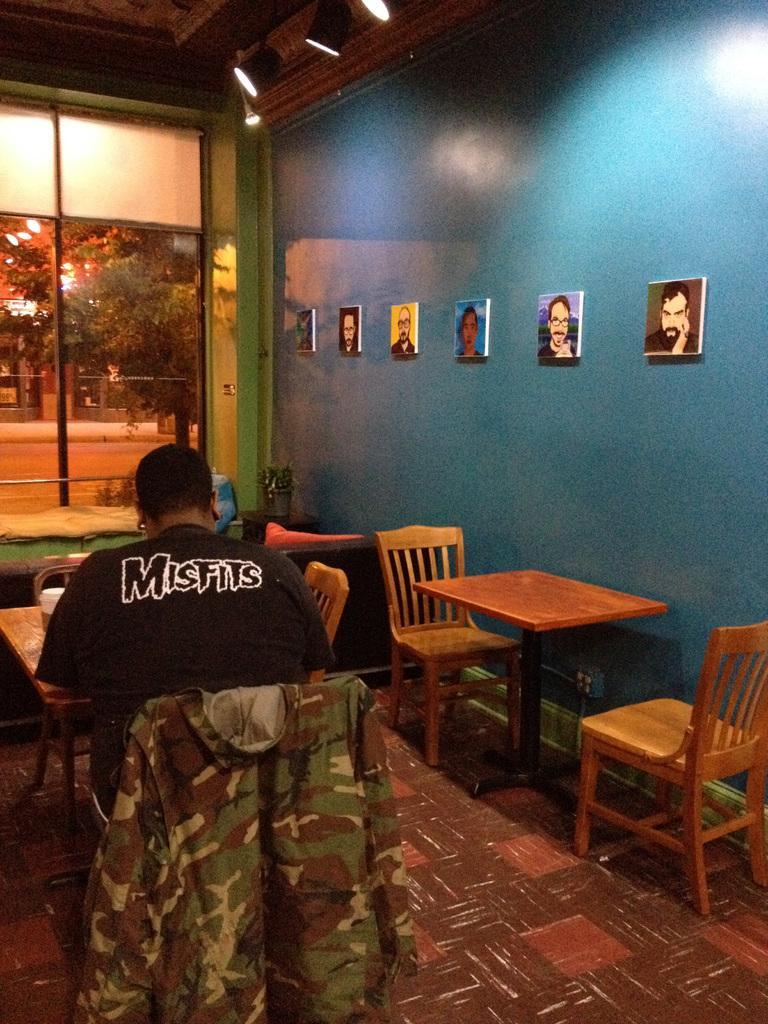In one or two sentences, can you explain what this image depicts? In this image In the middle there is a table on that there is a cup, in front of that table there is a man he wear black t shirt he is sitting on the chair. On the right there is a table and chairs and wall, photo frame and light. In the background there is a window, glass, trees and road. 